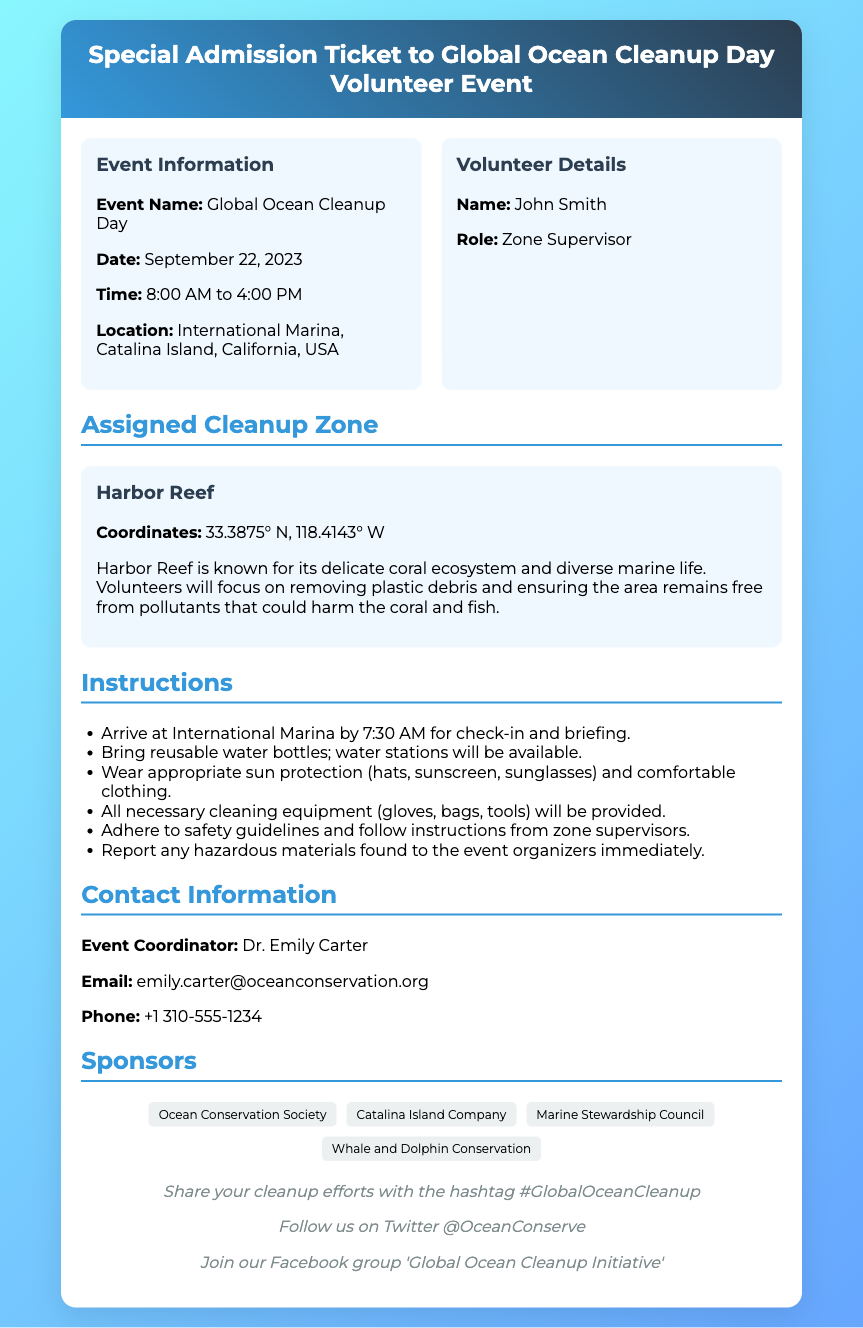What is the event name? The event name is stated in the ticket information section of the document.
Answer: Global Ocean Cleanup Day What is the date of the event? The date of the event is specified in the ticket information.
Answer: September 22, 2023 Who is the zone supervisor? The name of the zone supervisor is listed under volunteer details in the document.
Answer: John Smith What time does the event start? The starting time of the event is indicated in the ticket information.
Answer: 8:00 AM What is the location of the event? The location of the event is provided in the information section of the ticket.
Answer: International Marina, Catalina Island, California, USA What are volunteers advised to wear? The guidelines include recommendations for clothing and sun protection.
Answer: Comfortable clothing What is the assigned cleanup zone? The specific cleanup zone assigned is mentioned in the document.
Answer: Harbor Reef Who is the event coordinator? The event coordinator’s name is listed in the contact information section.
Answer: Dr. Emily Carter What should volunteers bring with them? The instructions specify items volunteers need to bring for the event.
Answer: Reusable water bottles 